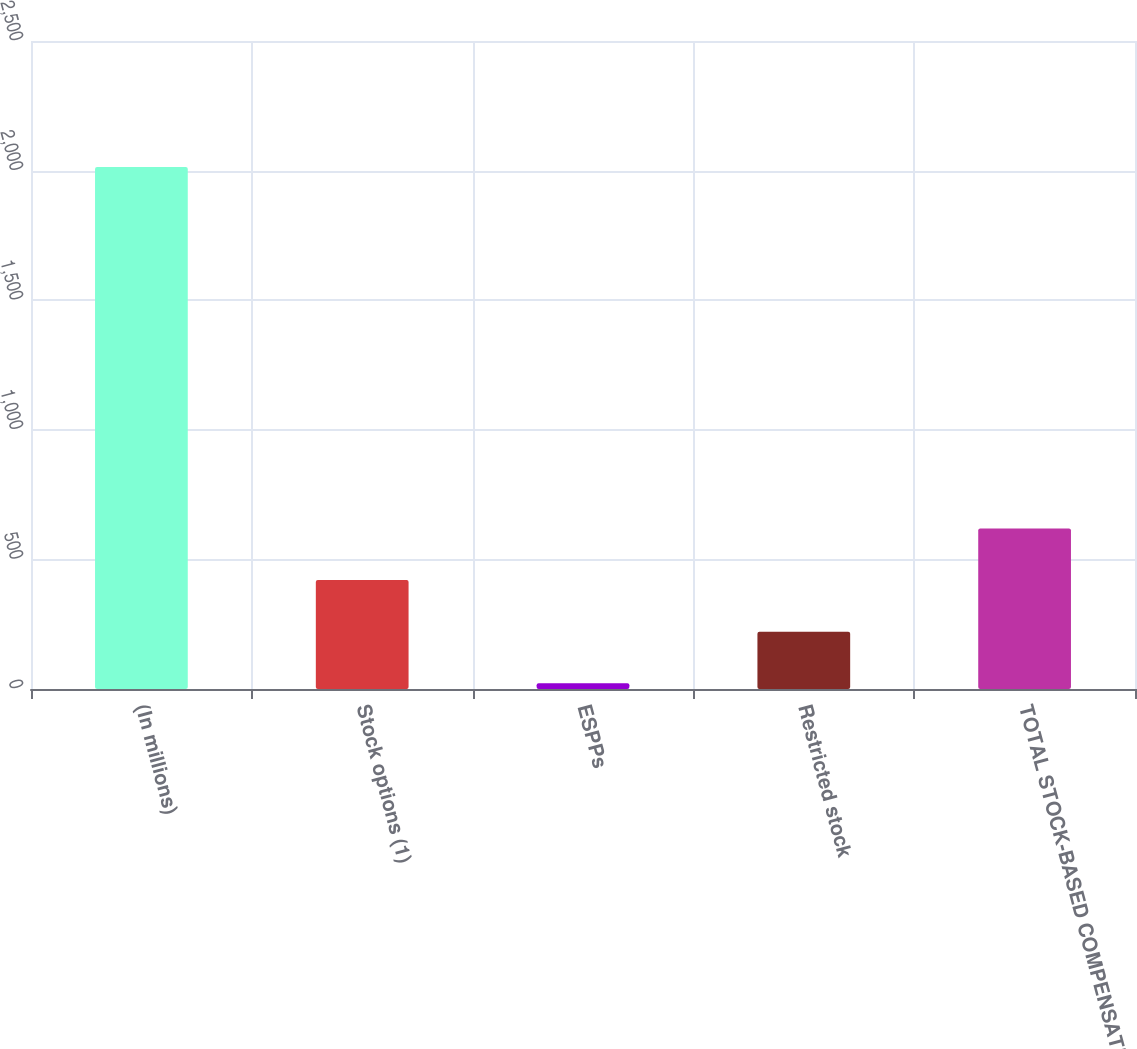Convert chart to OTSL. <chart><loc_0><loc_0><loc_500><loc_500><bar_chart><fcel>(In millions)<fcel>Stock options (1)<fcel>ESPPs<fcel>Restricted stock<fcel>TOTAL STOCK-BASED COMPENSATION<nl><fcel>2014<fcel>420.4<fcel>22<fcel>221.2<fcel>619.6<nl></chart> 